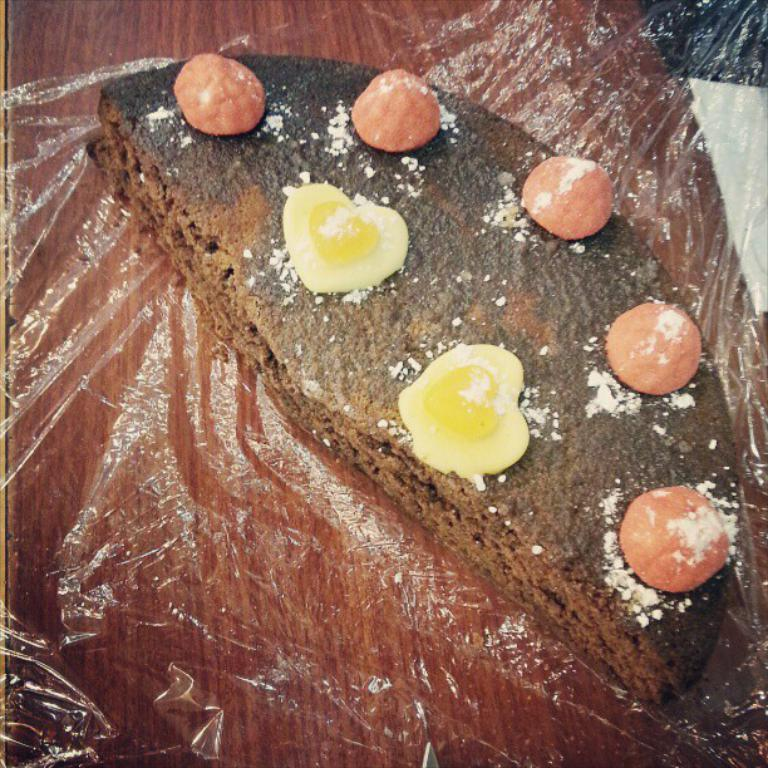What is the color of the surface on which the food is placed in the image? The surface is brown. What colors can be seen in the food in the image? The food has red, yellow, and brown colors. What type of cover is present on the table in the image? There is a plastic cover on the table. What route does the writer take to reach the beam in the image? There is no writer or beam present in the image. 